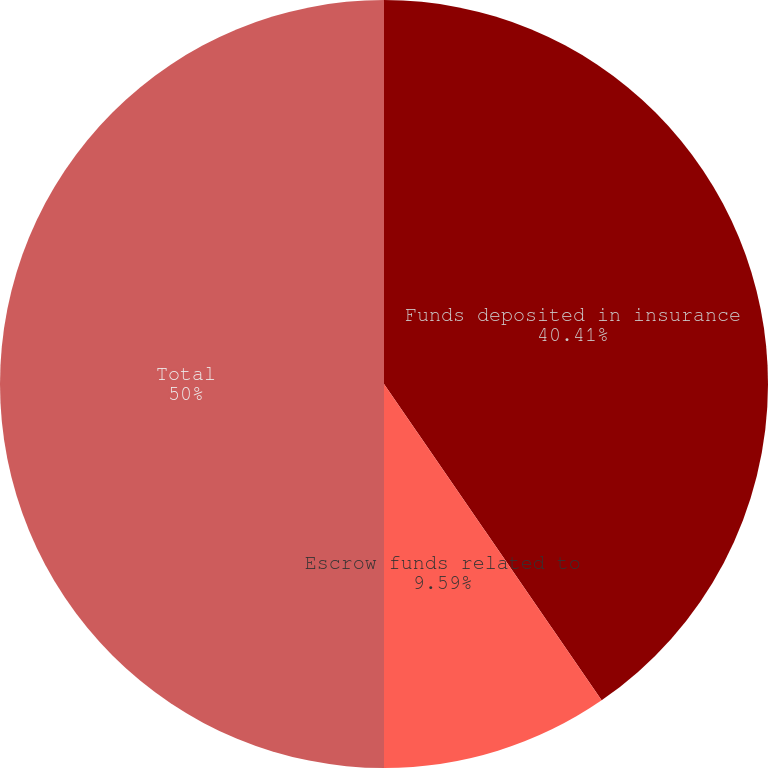Convert chart to OTSL. <chart><loc_0><loc_0><loc_500><loc_500><pie_chart><fcel>Funds deposited in insurance<fcel>Escrow funds related to<fcel>Total<nl><fcel>40.41%<fcel>9.59%<fcel>50.0%<nl></chart> 